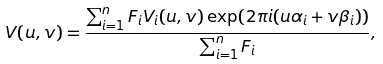Convert formula to latex. <formula><loc_0><loc_0><loc_500><loc_500>V ( u , v ) = \frac { \sum ^ { n } _ { i = 1 } F _ { i } V _ { i } ( u , v ) \exp ( 2 \pi i ( u \alpha _ { i } + v \beta _ { i } ) ) } { \sum ^ { n } _ { i = 1 } F _ { i } } ,</formula> 